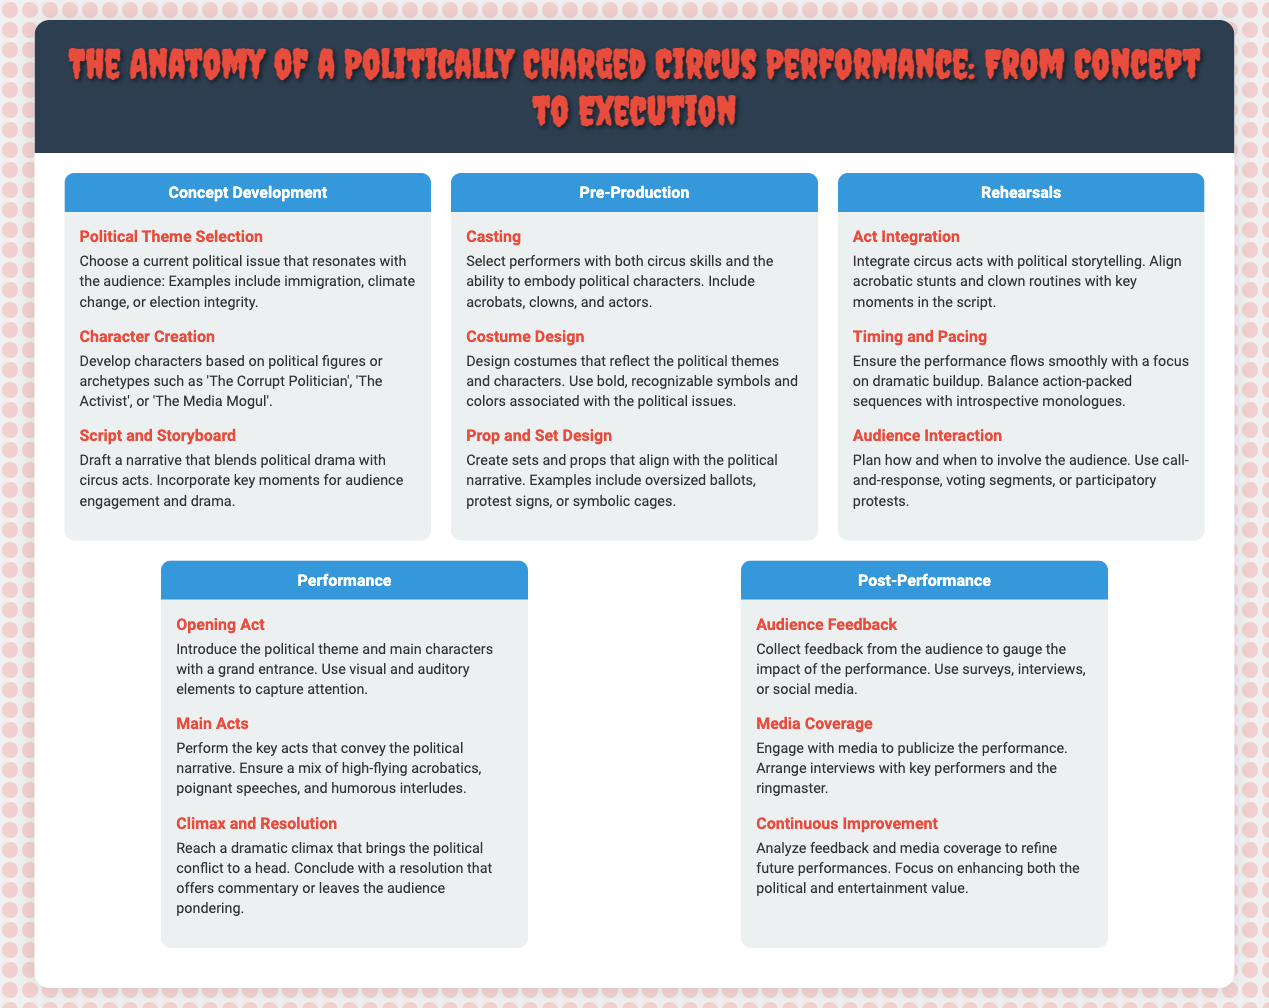What is the first step in Concept Development? The first step in Concept Development is Political Theme Selection, which focuses on choosing a current political issue.
Answer: Political Theme Selection How many sections are in the infographic? The infographic consists of five sections: Concept Development, Pre-Production, Rehearsals, Performance, and Post-Performance.
Answer: Five What role do the characters play in a circus performance? Characters are developed based on political figures or archetypes to embody specific ideas or conflicts in the performance.
Answer: Embody political figures Which step discusses involving the audience? The step that discusses involving the audience is Audience Interaction, which plans how and when to engage with the audience.
Answer: Audience Interaction What is included in the Main Acts? The Main Acts include key acts that convey the political narrative, featuring a mix of acrobatics and speeches.
Answer: Key acts What feedback method is mentioned for gauging impact? The method mentioned for collecting feedback is surveys, interviews, or social media to understand audience reception.
Answer: Surveys What is the primary purpose of Continuous Improvement? The primary purpose of Continuous Improvement is to analyze feedback and media coverage to improve future performances.
Answer: Improve future performances What is the central theme of the infographic? The central theme of the infographic is the process of creating a politically charged circus performance from concept to execution.
Answer: Politically charged circus performance 